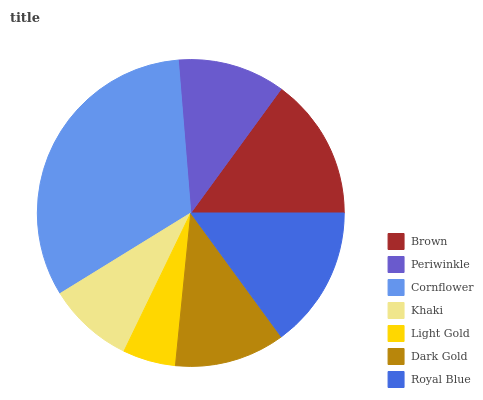Is Light Gold the minimum?
Answer yes or no. Yes. Is Cornflower the maximum?
Answer yes or no. Yes. Is Periwinkle the minimum?
Answer yes or no. No. Is Periwinkle the maximum?
Answer yes or no. No. Is Brown greater than Periwinkle?
Answer yes or no. Yes. Is Periwinkle less than Brown?
Answer yes or no. Yes. Is Periwinkle greater than Brown?
Answer yes or no. No. Is Brown less than Periwinkle?
Answer yes or no. No. Is Dark Gold the high median?
Answer yes or no. Yes. Is Dark Gold the low median?
Answer yes or no. Yes. Is Khaki the high median?
Answer yes or no. No. Is Periwinkle the low median?
Answer yes or no. No. 